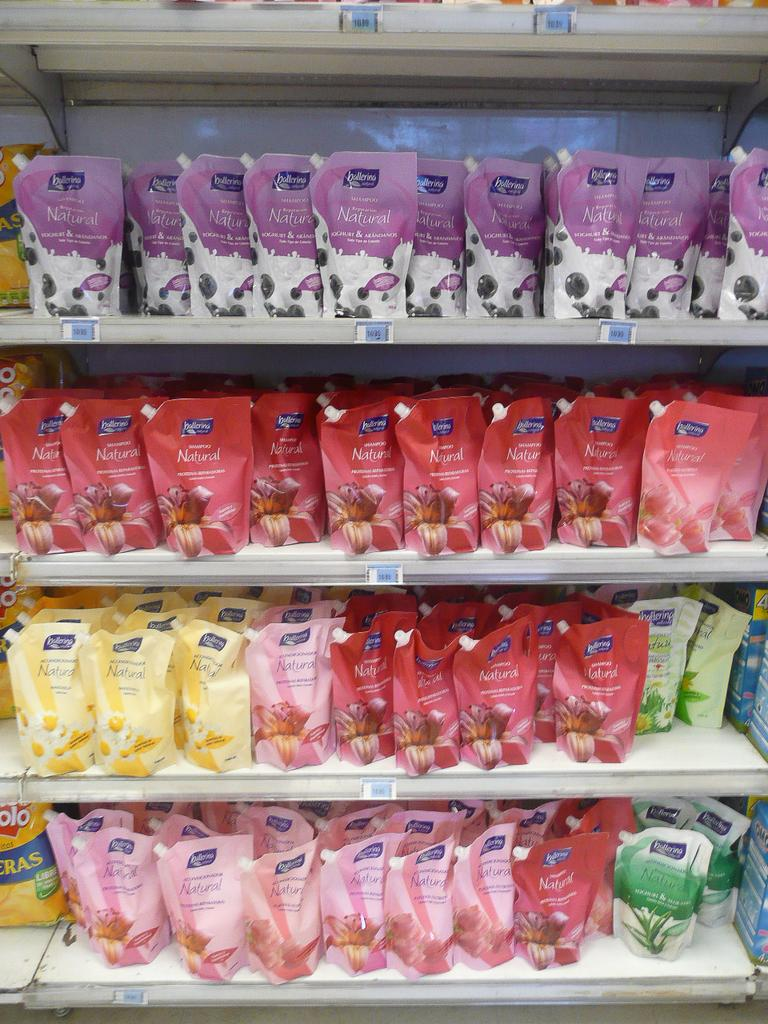Provide a one-sentence caption for the provided image. a group of candies with have ballerina written on them. 